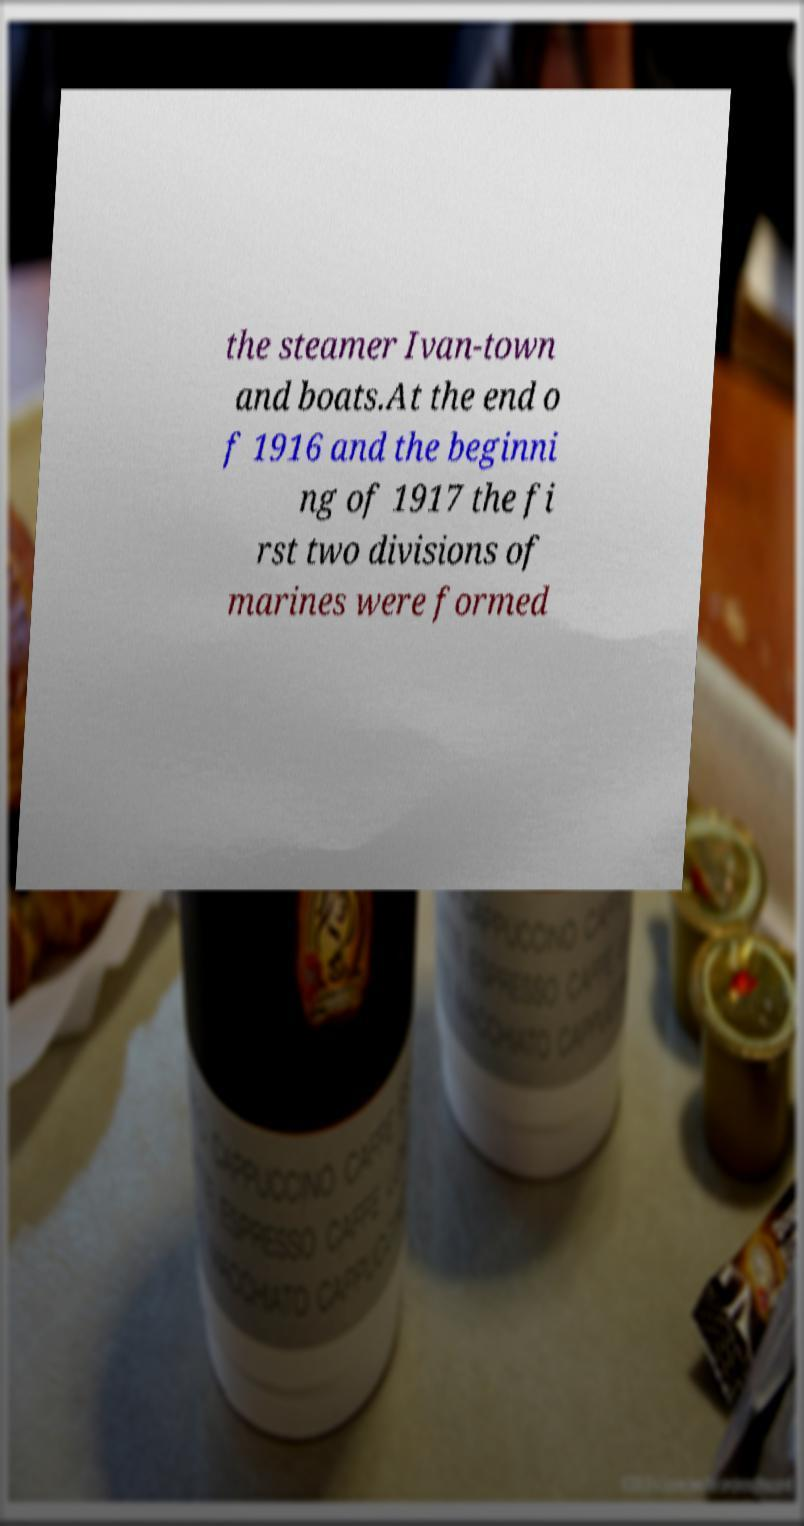Can you accurately transcribe the text from the provided image for me? the steamer Ivan-town and boats.At the end o f 1916 and the beginni ng of 1917 the fi rst two divisions of marines were formed 